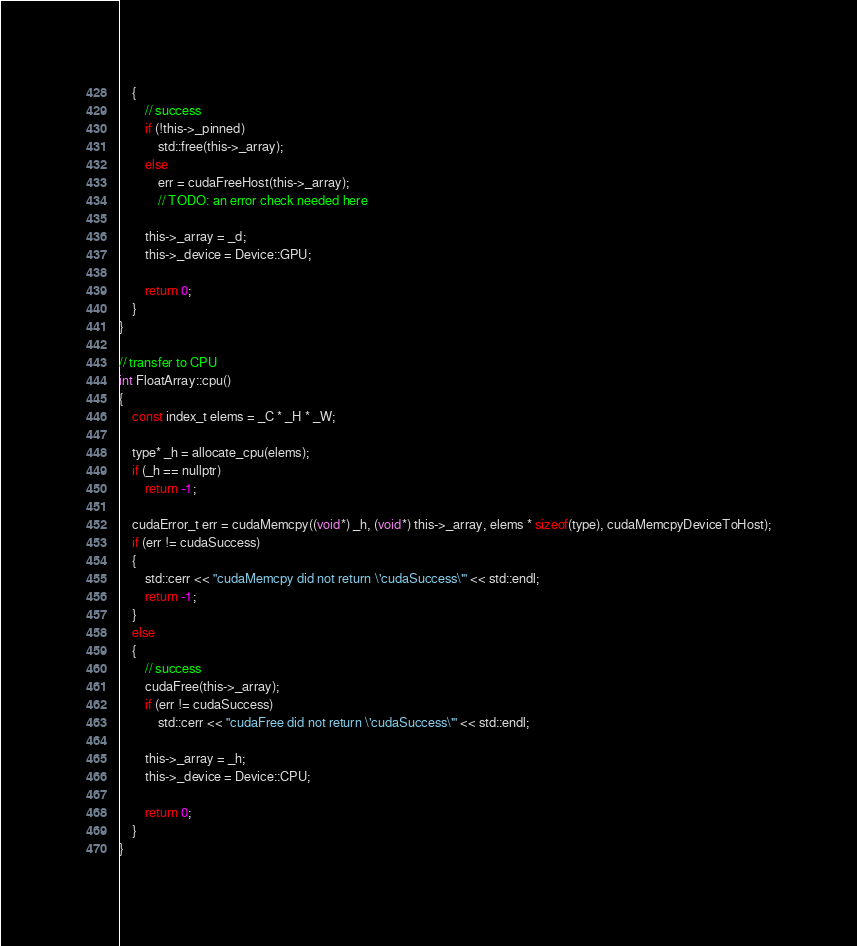<code> <loc_0><loc_0><loc_500><loc_500><_Cuda_>	{
		// success
		if (!this->_pinned)
			std::free(this->_array);
		else
			err = cudaFreeHost(this->_array);
			// TODO: an error check needed here

		this->_array = _d;
		this->_device = Device::GPU;

		return 0;
	}
}

// transfer to CPU
int FloatArray::cpu()
{
	const index_t elems = _C * _H * _W;
	
	type* _h = allocate_cpu(elems);
	if (_h == nullptr)
		return -1;

	cudaError_t err = cudaMemcpy((void*) _h, (void*) this->_array, elems * sizeof(type), cudaMemcpyDeviceToHost);
	if (err != cudaSuccess)
	{
		std::cerr << "cudaMemcpy did not return \'cudaSuccess\'" << std::endl;
		return -1;
	}
	else
	{
		// success
		cudaFree(this->_array);
		if (err != cudaSuccess)
			std::cerr << "cudaFree did not return \'cudaSuccess\'" << std::endl;

		this->_array = _h;
		this->_device = Device::CPU;

		return 0;
	}
}</code> 